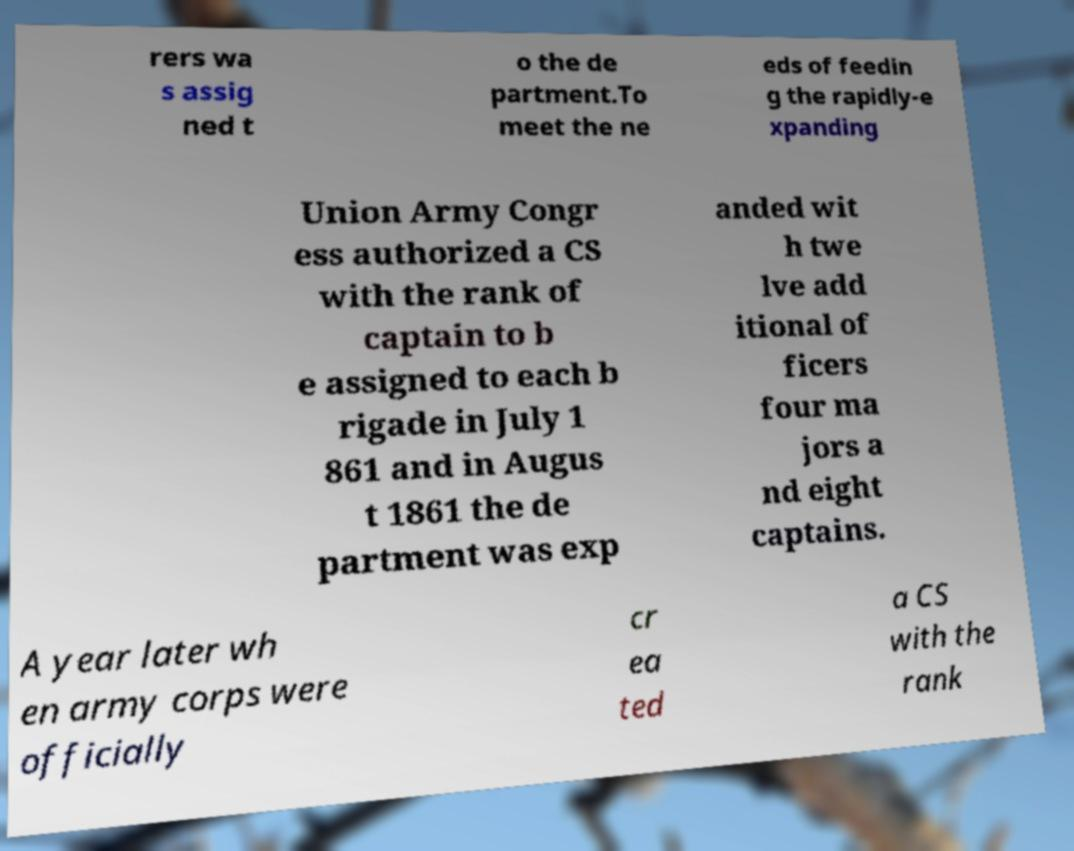There's text embedded in this image that I need extracted. Can you transcribe it verbatim? rers wa s assig ned t o the de partment.To meet the ne eds of feedin g the rapidly-e xpanding Union Army Congr ess authorized a CS with the rank of captain to b e assigned to each b rigade in July 1 861 and in Augus t 1861 the de partment was exp anded wit h twe lve add itional of ficers four ma jors a nd eight captains. A year later wh en army corps were officially cr ea ted a CS with the rank 